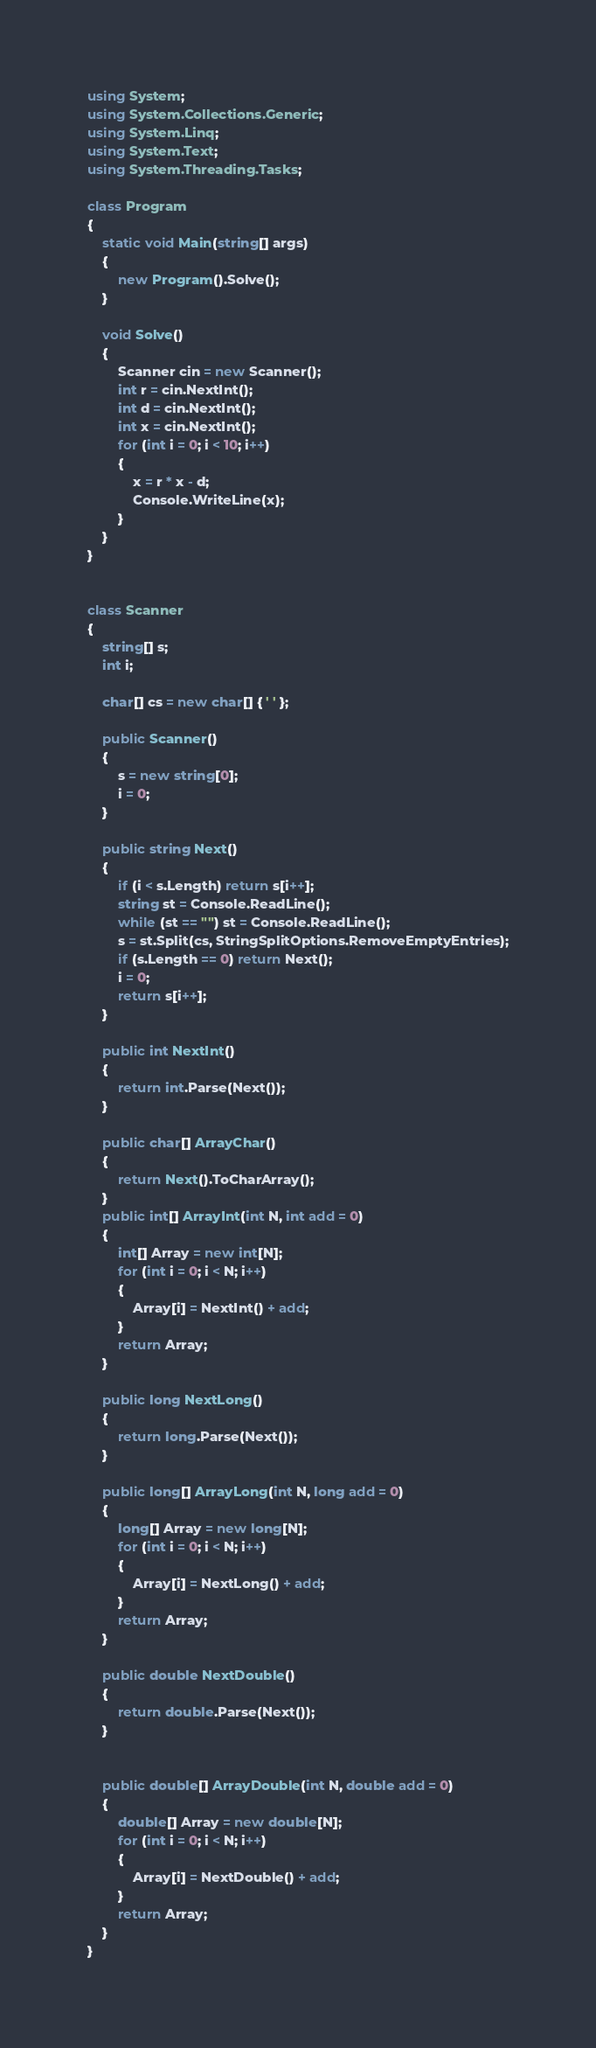<code> <loc_0><loc_0><loc_500><loc_500><_C#_>using System;
using System.Collections.Generic;
using System.Linq;
using System.Text;
using System.Threading.Tasks;

class Program
{
    static void Main(string[] args)
    {
        new Program().Solve();
    }

    void Solve()
    {
        Scanner cin = new Scanner();
        int r = cin.NextInt();
        int d = cin.NextInt();
        int x = cin.NextInt();
        for (int i = 0; i < 10; i++)
        {
            x = r * x - d;
            Console.WriteLine(x);
        }
    }
}


class Scanner
{
    string[] s;
    int i;

    char[] cs = new char[] { ' ' };

    public Scanner()
    {
        s = new string[0];
        i = 0;
    }

    public string Next()
    {
        if (i < s.Length) return s[i++];
        string st = Console.ReadLine();
        while (st == "") st = Console.ReadLine();
        s = st.Split(cs, StringSplitOptions.RemoveEmptyEntries);
        if (s.Length == 0) return Next();
        i = 0;
        return s[i++];
    }

    public int NextInt()
    {
        return int.Parse(Next());
    }

    public char[] ArrayChar()
    {
        return Next().ToCharArray();
    }
    public int[] ArrayInt(int N, int add = 0)
    {
        int[] Array = new int[N];
        for (int i = 0; i < N; i++)
        {
            Array[i] = NextInt() + add;
        }
        return Array;
    }

    public long NextLong()
    {
        return long.Parse(Next());
    }

    public long[] ArrayLong(int N, long add = 0)
    {
        long[] Array = new long[N];
        for (int i = 0; i < N; i++)
        {
            Array[i] = NextLong() + add;
        }
        return Array;
    }

    public double NextDouble()
    {
        return double.Parse(Next());
    }


    public double[] ArrayDouble(int N, double add = 0)
    {
        double[] Array = new double[N];
        for (int i = 0; i < N; i++)
        {
            Array[i] = NextDouble() + add;
        }
        return Array;
    }
}</code> 